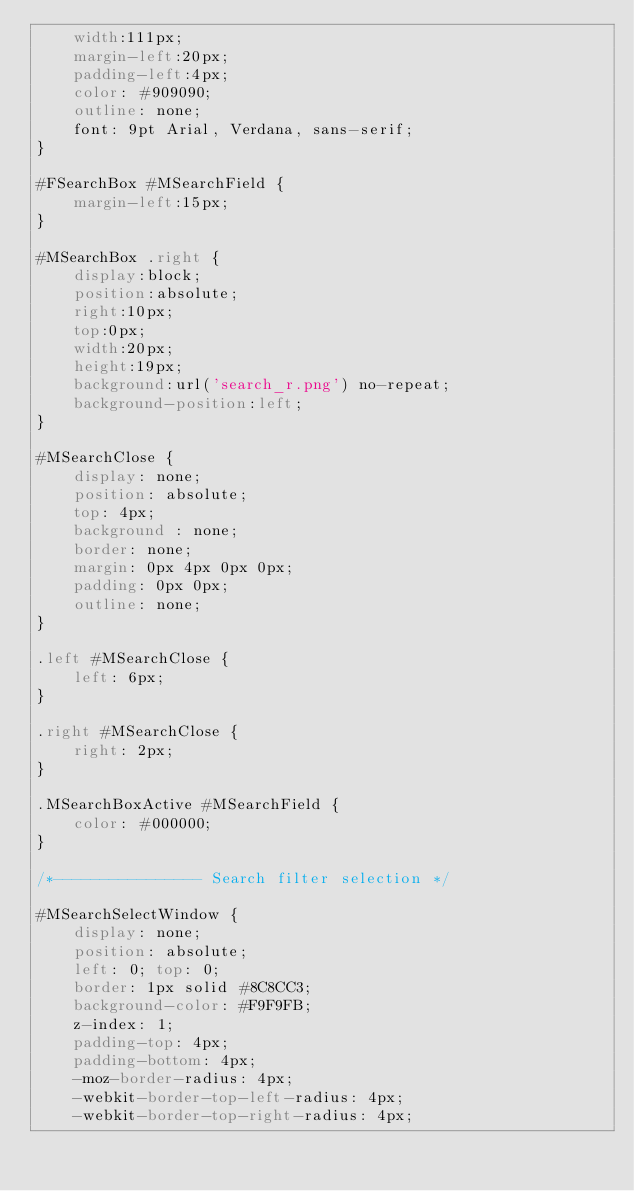<code> <loc_0><loc_0><loc_500><loc_500><_CSS_>    width:111px;
    margin-left:20px;
    padding-left:4px;
    color: #909090;
    outline: none;
    font: 9pt Arial, Verdana, sans-serif;
}

#FSearchBox #MSearchField {
    margin-left:15px;
}

#MSearchBox .right {
    display:block;
    position:absolute;
    right:10px;
    top:0px;
    width:20px;
    height:19px;
    background:url('search_r.png') no-repeat;
    background-position:left;
}

#MSearchClose {
    display: none;
    position: absolute;
    top: 4px;
    background : none;
    border: none;
    margin: 0px 4px 0px 0px;
    padding: 0px 0px;
    outline: none;
}

.left #MSearchClose {
    left: 6px;
}

.right #MSearchClose {
    right: 2px;
}

.MSearchBoxActive #MSearchField {
    color: #000000;
}

/*---------------- Search filter selection */

#MSearchSelectWindow {
    display: none;
    position: absolute;
    left: 0; top: 0;
    border: 1px solid #8C8CC3;
    background-color: #F9F9FB;
    z-index: 1;
    padding-top: 4px;
    padding-bottom: 4px;
    -moz-border-radius: 4px;
    -webkit-border-top-left-radius: 4px;
    -webkit-border-top-right-radius: 4px;</code> 